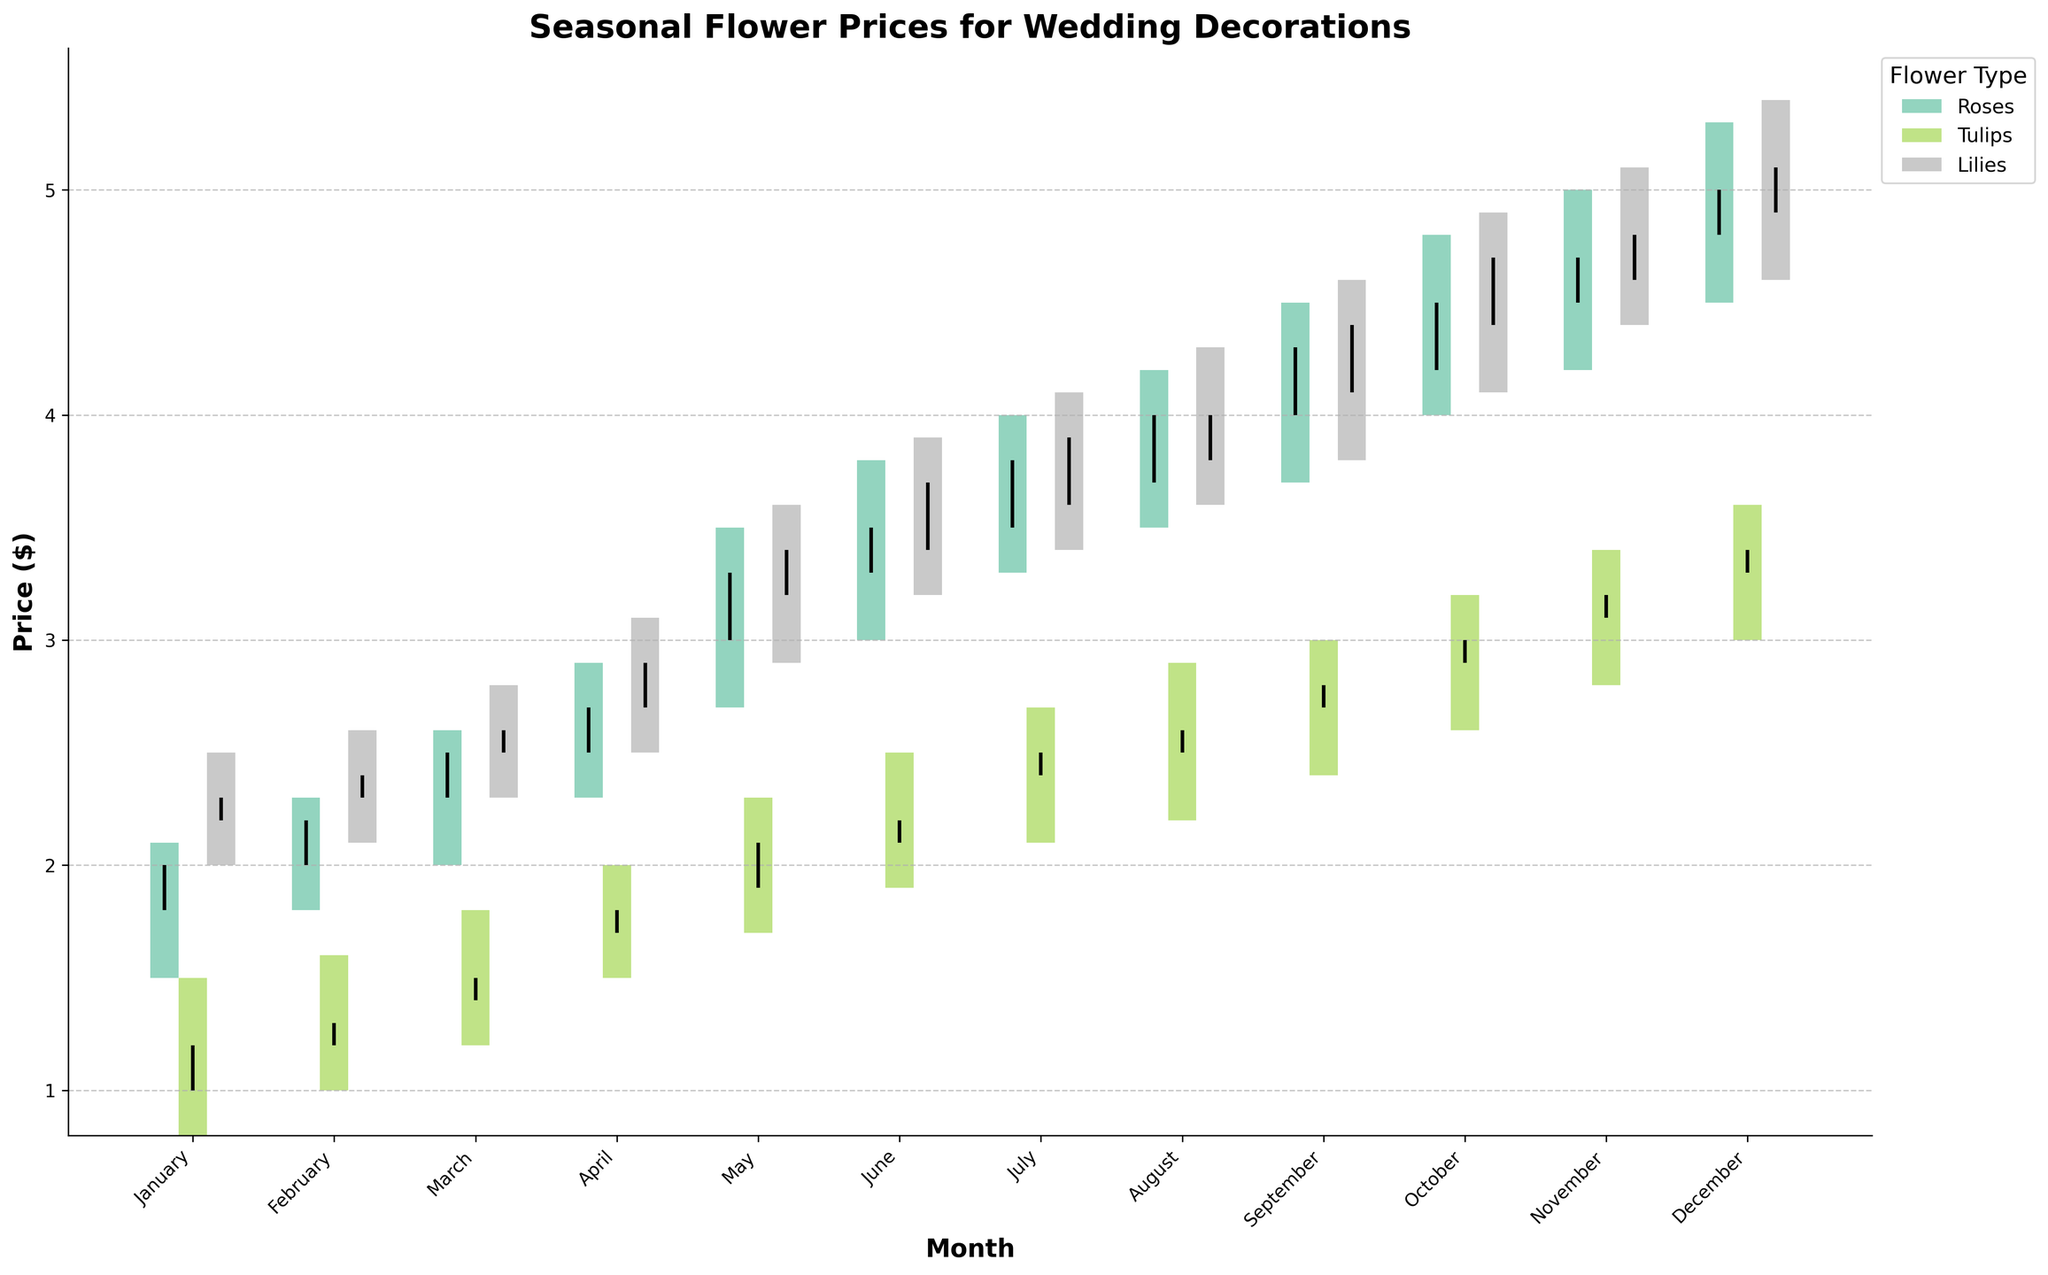What is the title of the figure? The title of the figure is usually displayed at the top and summarizes the content. In this case, it states the main theme of the plot.
Answer: Seasonal Flower Prices for Wedding Decorations How is the price variation represented for each month and flower type? Price variation is represented using bars and vertical lines. The bars show the range from the lowest to the highest price, and the vertical lines indicate the opening and closing prices.
Answer: Bars and vertical lines What is the price range for Roses in January? The price range for Roses in January is calculated by looking at the lowest and highest prices for this month. The lowest price is $1.5, and the highest price is $2.1.
Answer: $1.5 to $2.1 Which flower type had the highest closing price in December? To find the highest closing price, check the closing prices for all flower types in December and identify the highest value. Lilies had a closing price of $5.1, which is the highest.
Answer: Lilies During which month did Tulips have the greatest difference between opening and closing prices? Calculate the difference between opening and closing prices for each month for Tulips, then find the month with the greatest difference. In April, the difference is $1.7 - $1.8 = -$0.1, the smallest among all months. In other months, the differences are greater.
Answer: February Which month showed the highest price range for Lilies? To determine this, find the price range (High - Low) for Lilies in each month and identify the largest range. In October, Lilies had a range of $4.9 - $4.1 = $0.8, the highest among all months.
Answer: October What are the opening prices for Roses in March, April, and May? Check the opening prices for Roses in the specified months: March ($2.3), April ($2.5), and May ($3.0).
Answer: $2.3, $2.5, and $3.0 During which month did Roses have their highest closing price, and what was it? Look at the closing prices for Roses across all months and find the highest closing price: December with a closing price of $5.0.
Answer: December, $5.0 Compare the price range of Tulips in February to Roses in July. Which flower had a greater range? Calculate the price range for Tulips in February ($1.6 - $1.0 = $0.6) and Roses in July ($4.0 - $3.3 = $0.7), then compare them. Roses had a greater range than Tulips.
Answer: Roses had a greater range How do the opening prices of Lilies in January and July compare? Check the opening prices for Lilies in January ($2.2) and July ($3.6) and compare them. The opening price in July is higher.
Answer: Lilies had a higher opening price in July What is the annual trend in the closing prices of Roses? Observing the closing prices of Roses each month shows an increase from January to December, indicating a rising trend throughout the year.
Answer: Rising trend 